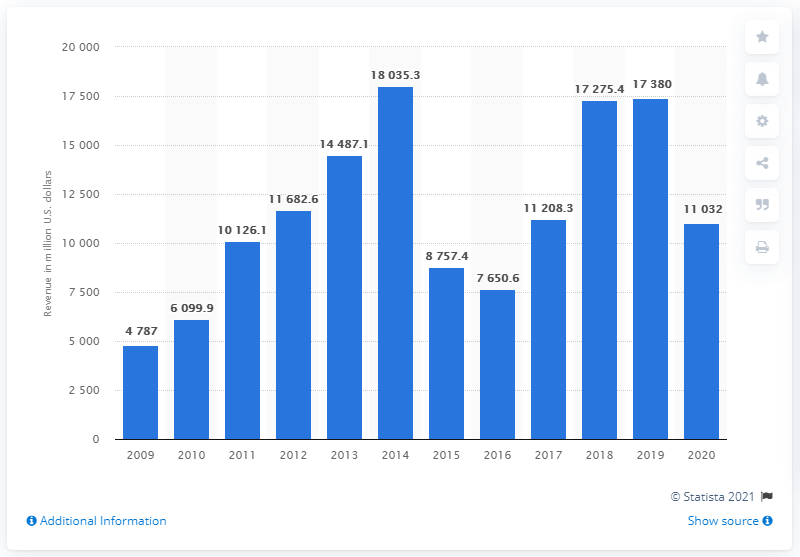Draw attention to some important aspects in this diagram. In 2020, EOG Resources generated approximately $11,208.3 million in revenue. 